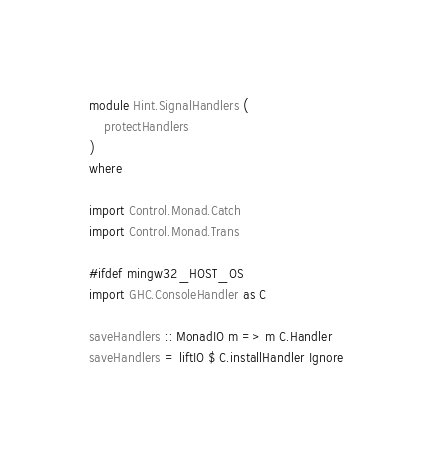Convert code to text. <code><loc_0><loc_0><loc_500><loc_500><_Haskell_>module Hint.SignalHandlers (
    protectHandlers
)
where

import Control.Monad.Catch
import Control.Monad.Trans

#ifdef mingw32_HOST_OS
import GHC.ConsoleHandler as C

saveHandlers :: MonadIO m => m C.Handler
saveHandlers = liftIO $ C.installHandler Ignore
</code> 